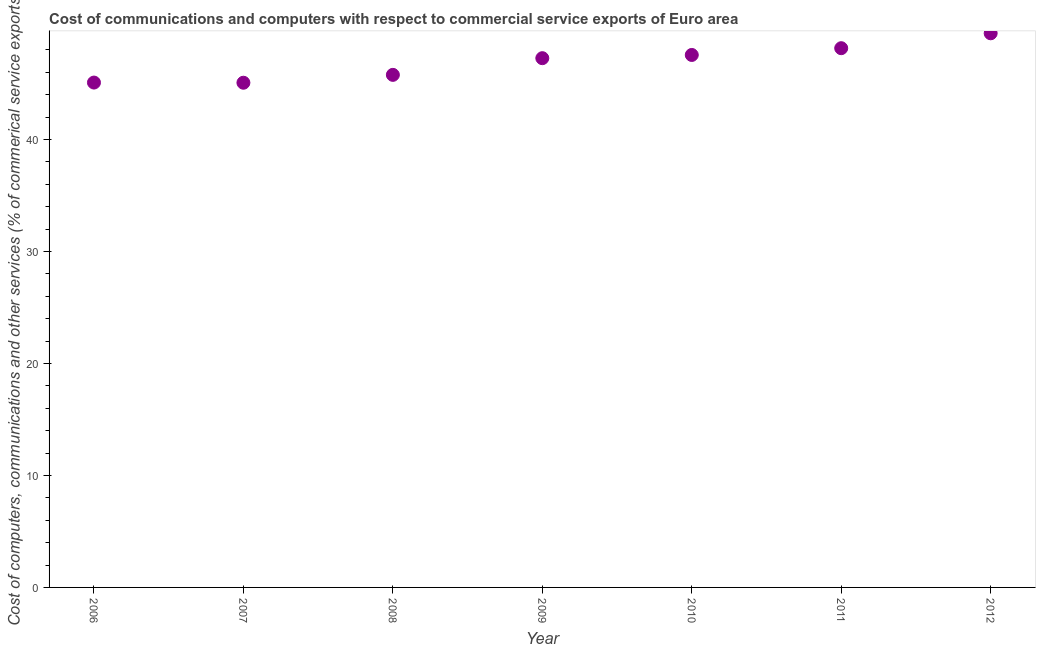What is the  computer and other services in 2011?
Keep it short and to the point. 48.15. Across all years, what is the maximum cost of communications?
Your response must be concise. 49.48. Across all years, what is the minimum cost of communications?
Provide a short and direct response. 45.07. In which year was the  computer and other services minimum?
Make the answer very short. 2007. What is the sum of the cost of communications?
Your answer should be compact. 328.36. What is the difference between the  computer and other services in 2009 and 2010?
Your answer should be very brief. -0.29. What is the average  computer and other services per year?
Your answer should be compact. 46.91. What is the median  computer and other services?
Ensure brevity in your answer.  47.26. What is the ratio of the cost of communications in 2010 to that in 2011?
Your response must be concise. 0.99. Is the  computer and other services in 2008 less than that in 2009?
Your answer should be very brief. Yes. What is the difference between the highest and the second highest cost of communications?
Your answer should be compact. 1.33. What is the difference between the highest and the lowest cost of communications?
Provide a short and direct response. 4.41. In how many years, is the  computer and other services greater than the average  computer and other services taken over all years?
Keep it short and to the point. 4. How many years are there in the graph?
Your answer should be compact. 7. What is the difference between two consecutive major ticks on the Y-axis?
Ensure brevity in your answer.  10. Does the graph contain grids?
Make the answer very short. No. What is the title of the graph?
Offer a very short reply. Cost of communications and computers with respect to commercial service exports of Euro area. What is the label or title of the Y-axis?
Keep it short and to the point. Cost of computers, communications and other services (% of commerical service exports). What is the Cost of computers, communications and other services (% of commerical service exports) in 2006?
Keep it short and to the point. 45.08. What is the Cost of computers, communications and other services (% of commerical service exports) in 2007?
Your answer should be very brief. 45.07. What is the Cost of computers, communications and other services (% of commerical service exports) in 2008?
Your answer should be compact. 45.77. What is the Cost of computers, communications and other services (% of commerical service exports) in 2009?
Your answer should be very brief. 47.26. What is the Cost of computers, communications and other services (% of commerical service exports) in 2010?
Keep it short and to the point. 47.55. What is the Cost of computers, communications and other services (% of commerical service exports) in 2011?
Make the answer very short. 48.15. What is the Cost of computers, communications and other services (% of commerical service exports) in 2012?
Your answer should be compact. 49.48. What is the difference between the Cost of computers, communications and other services (% of commerical service exports) in 2006 and 2007?
Provide a short and direct response. 0.02. What is the difference between the Cost of computers, communications and other services (% of commerical service exports) in 2006 and 2008?
Your answer should be very brief. -0.69. What is the difference between the Cost of computers, communications and other services (% of commerical service exports) in 2006 and 2009?
Ensure brevity in your answer.  -2.18. What is the difference between the Cost of computers, communications and other services (% of commerical service exports) in 2006 and 2010?
Provide a short and direct response. -2.47. What is the difference between the Cost of computers, communications and other services (% of commerical service exports) in 2006 and 2011?
Ensure brevity in your answer.  -3.07. What is the difference between the Cost of computers, communications and other services (% of commerical service exports) in 2006 and 2012?
Ensure brevity in your answer.  -4.4. What is the difference between the Cost of computers, communications and other services (% of commerical service exports) in 2007 and 2008?
Give a very brief answer. -0.7. What is the difference between the Cost of computers, communications and other services (% of commerical service exports) in 2007 and 2009?
Offer a terse response. -2.19. What is the difference between the Cost of computers, communications and other services (% of commerical service exports) in 2007 and 2010?
Offer a very short reply. -2.48. What is the difference between the Cost of computers, communications and other services (% of commerical service exports) in 2007 and 2011?
Ensure brevity in your answer.  -3.08. What is the difference between the Cost of computers, communications and other services (% of commerical service exports) in 2007 and 2012?
Your response must be concise. -4.41. What is the difference between the Cost of computers, communications and other services (% of commerical service exports) in 2008 and 2009?
Give a very brief answer. -1.49. What is the difference between the Cost of computers, communications and other services (% of commerical service exports) in 2008 and 2010?
Your answer should be very brief. -1.78. What is the difference between the Cost of computers, communications and other services (% of commerical service exports) in 2008 and 2011?
Offer a terse response. -2.38. What is the difference between the Cost of computers, communications and other services (% of commerical service exports) in 2008 and 2012?
Your answer should be very brief. -3.71. What is the difference between the Cost of computers, communications and other services (% of commerical service exports) in 2009 and 2010?
Offer a very short reply. -0.29. What is the difference between the Cost of computers, communications and other services (% of commerical service exports) in 2009 and 2011?
Give a very brief answer. -0.89. What is the difference between the Cost of computers, communications and other services (% of commerical service exports) in 2009 and 2012?
Give a very brief answer. -2.22. What is the difference between the Cost of computers, communications and other services (% of commerical service exports) in 2010 and 2011?
Offer a very short reply. -0.6. What is the difference between the Cost of computers, communications and other services (% of commerical service exports) in 2010 and 2012?
Ensure brevity in your answer.  -1.93. What is the difference between the Cost of computers, communications and other services (% of commerical service exports) in 2011 and 2012?
Provide a short and direct response. -1.33. What is the ratio of the Cost of computers, communications and other services (% of commerical service exports) in 2006 to that in 2007?
Provide a succinct answer. 1. What is the ratio of the Cost of computers, communications and other services (% of commerical service exports) in 2006 to that in 2008?
Make the answer very short. 0.98. What is the ratio of the Cost of computers, communications and other services (% of commerical service exports) in 2006 to that in 2009?
Your response must be concise. 0.95. What is the ratio of the Cost of computers, communications and other services (% of commerical service exports) in 2006 to that in 2010?
Keep it short and to the point. 0.95. What is the ratio of the Cost of computers, communications and other services (% of commerical service exports) in 2006 to that in 2011?
Make the answer very short. 0.94. What is the ratio of the Cost of computers, communications and other services (% of commerical service exports) in 2006 to that in 2012?
Keep it short and to the point. 0.91. What is the ratio of the Cost of computers, communications and other services (% of commerical service exports) in 2007 to that in 2008?
Keep it short and to the point. 0.98. What is the ratio of the Cost of computers, communications and other services (% of commerical service exports) in 2007 to that in 2009?
Provide a succinct answer. 0.95. What is the ratio of the Cost of computers, communications and other services (% of commerical service exports) in 2007 to that in 2010?
Give a very brief answer. 0.95. What is the ratio of the Cost of computers, communications and other services (% of commerical service exports) in 2007 to that in 2011?
Your response must be concise. 0.94. What is the ratio of the Cost of computers, communications and other services (% of commerical service exports) in 2007 to that in 2012?
Your answer should be very brief. 0.91. What is the ratio of the Cost of computers, communications and other services (% of commerical service exports) in 2008 to that in 2009?
Provide a short and direct response. 0.97. What is the ratio of the Cost of computers, communications and other services (% of commerical service exports) in 2008 to that in 2010?
Provide a short and direct response. 0.96. What is the ratio of the Cost of computers, communications and other services (% of commerical service exports) in 2008 to that in 2011?
Your response must be concise. 0.95. What is the ratio of the Cost of computers, communications and other services (% of commerical service exports) in 2008 to that in 2012?
Ensure brevity in your answer.  0.93. What is the ratio of the Cost of computers, communications and other services (% of commerical service exports) in 2009 to that in 2010?
Ensure brevity in your answer.  0.99. What is the ratio of the Cost of computers, communications and other services (% of commerical service exports) in 2009 to that in 2012?
Ensure brevity in your answer.  0.95. What is the ratio of the Cost of computers, communications and other services (% of commerical service exports) in 2010 to that in 2011?
Your response must be concise. 0.99. What is the ratio of the Cost of computers, communications and other services (% of commerical service exports) in 2010 to that in 2012?
Offer a terse response. 0.96. What is the ratio of the Cost of computers, communications and other services (% of commerical service exports) in 2011 to that in 2012?
Keep it short and to the point. 0.97. 